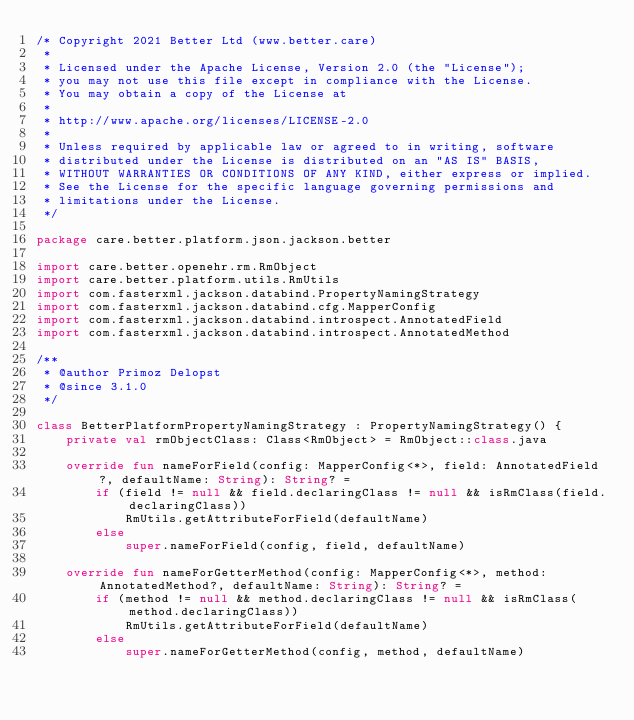Convert code to text. <code><loc_0><loc_0><loc_500><loc_500><_Kotlin_>/* Copyright 2021 Better Ltd (www.better.care)
 *
 * Licensed under the Apache License, Version 2.0 (the "License");
 * you may not use this file except in compliance with the License.
 * You may obtain a copy of the License at
 *
 * http://www.apache.org/licenses/LICENSE-2.0
 *
 * Unless required by applicable law or agreed to in writing, software
 * distributed under the License is distributed on an "AS IS" BASIS,
 * WITHOUT WARRANTIES OR CONDITIONS OF ANY KIND, either express or implied.
 * See the License for the specific language governing permissions and
 * limitations under the License.
 */

package care.better.platform.json.jackson.better

import care.better.openehr.rm.RmObject
import care.better.platform.utils.RmUtils
import com.fasterxml.jackson.databind.PropertyNamingStrategy
import com.fasterxml.jackson.databind.cfg.MapperConfig
import com.fasterxml.jackson.databind.introspect.AnnotatedField
import com.fasterxml.jackson.databind.introspect.AnnotatedMethod

/**
 * @author Primoz Delopst
 * @since 3.1.0
 */

class BetterPlatformPropertyNamingStrategy : PropertyNamingStrategy() {
    private val rmObjectClass: Class<RmObject> = RmObject::class.java

    override fun nameForField(config: MapperConfig<*>, field: AnnotatedField?, defaultName: String): String? =
        if (field != null && field.declaringClass != null && isRmClass(field.declaringClass))
            RmUtils.getAttributeForField(defaultName)
        else
            super.nameForField(config, field, defaultName)

    override fun nameForGetterMethod(config: MapperConfig<*>, method: AnnotatedMethod?, defaultName: String): String? =
        if (method != null && method.declaringClass != null && isRmClass(method.declaringClass))
            RmUtils.getAttributeForField(defaultName)
        else
            super.nameForGetterMethod(config, method, defaultName)
</code> 